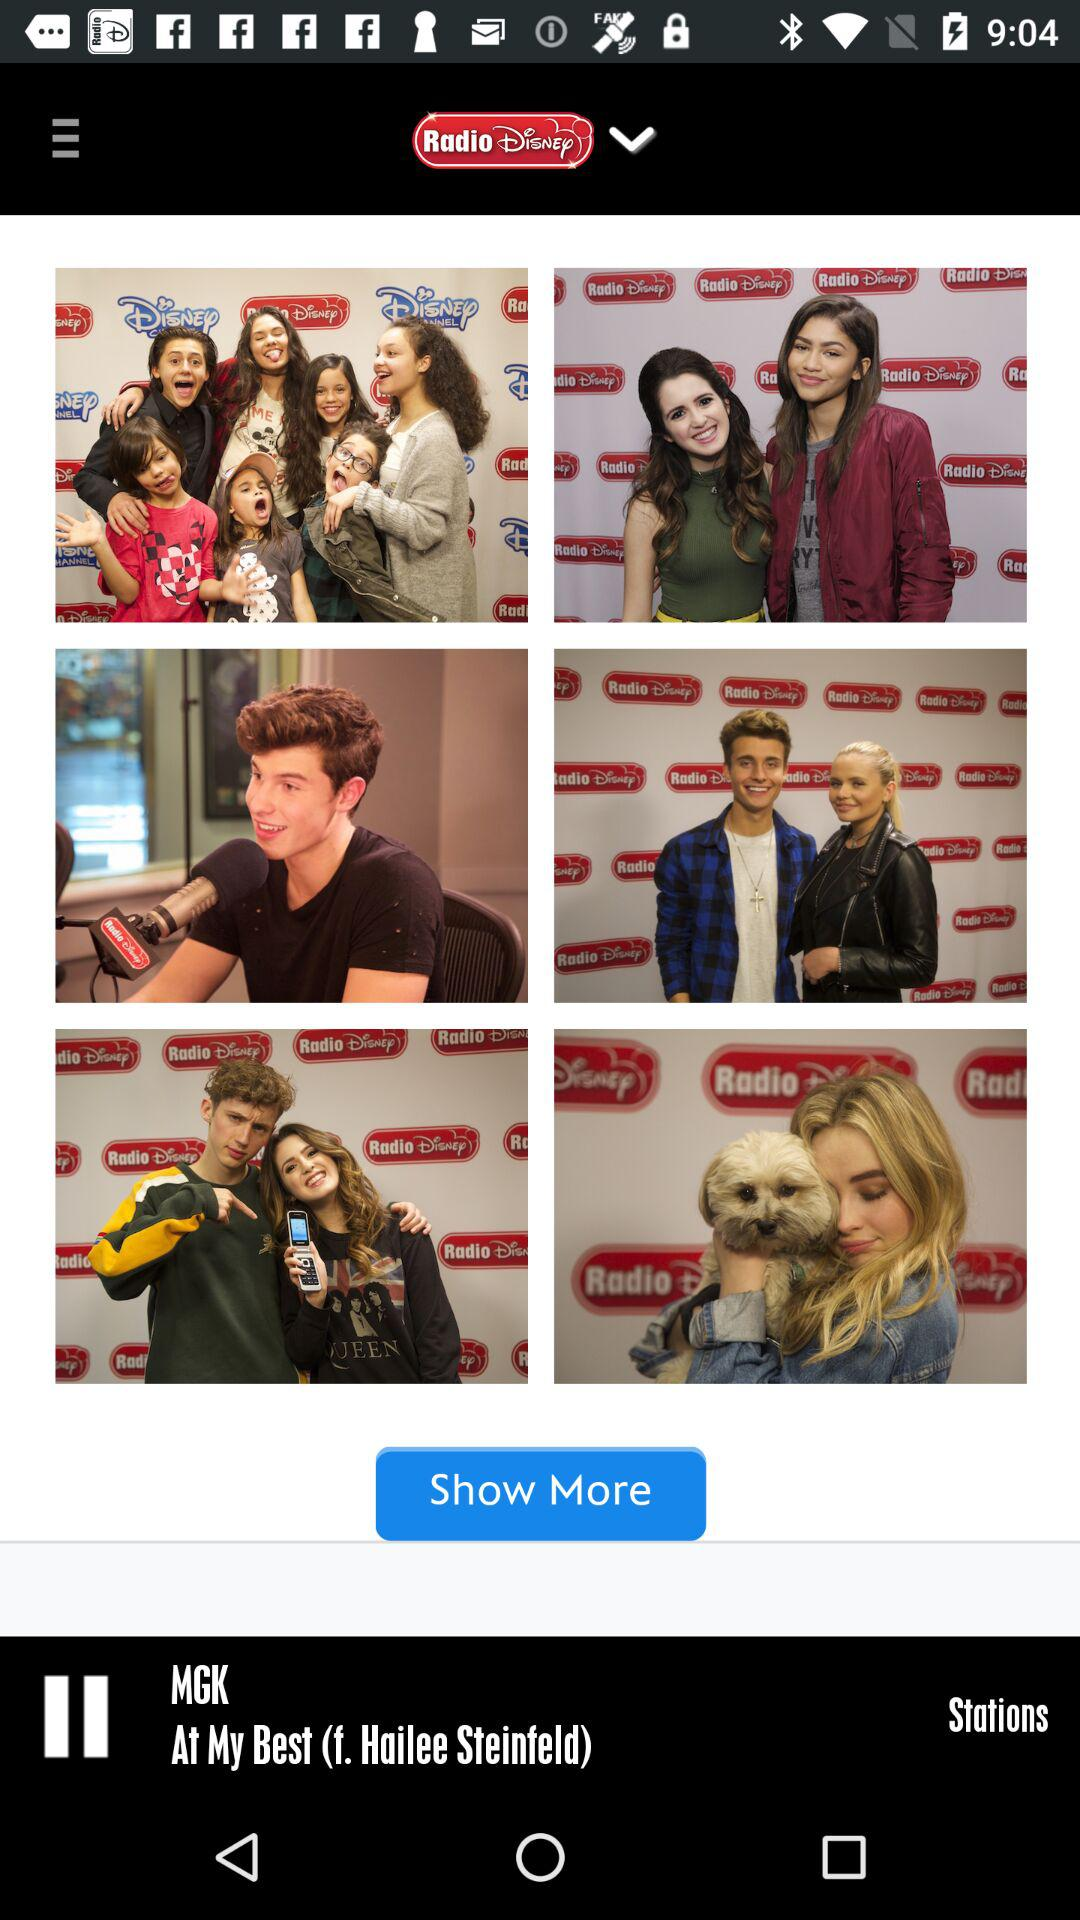What audio is playing? The audio playing is "At My Best (f. Hailee Steinfeld)". 